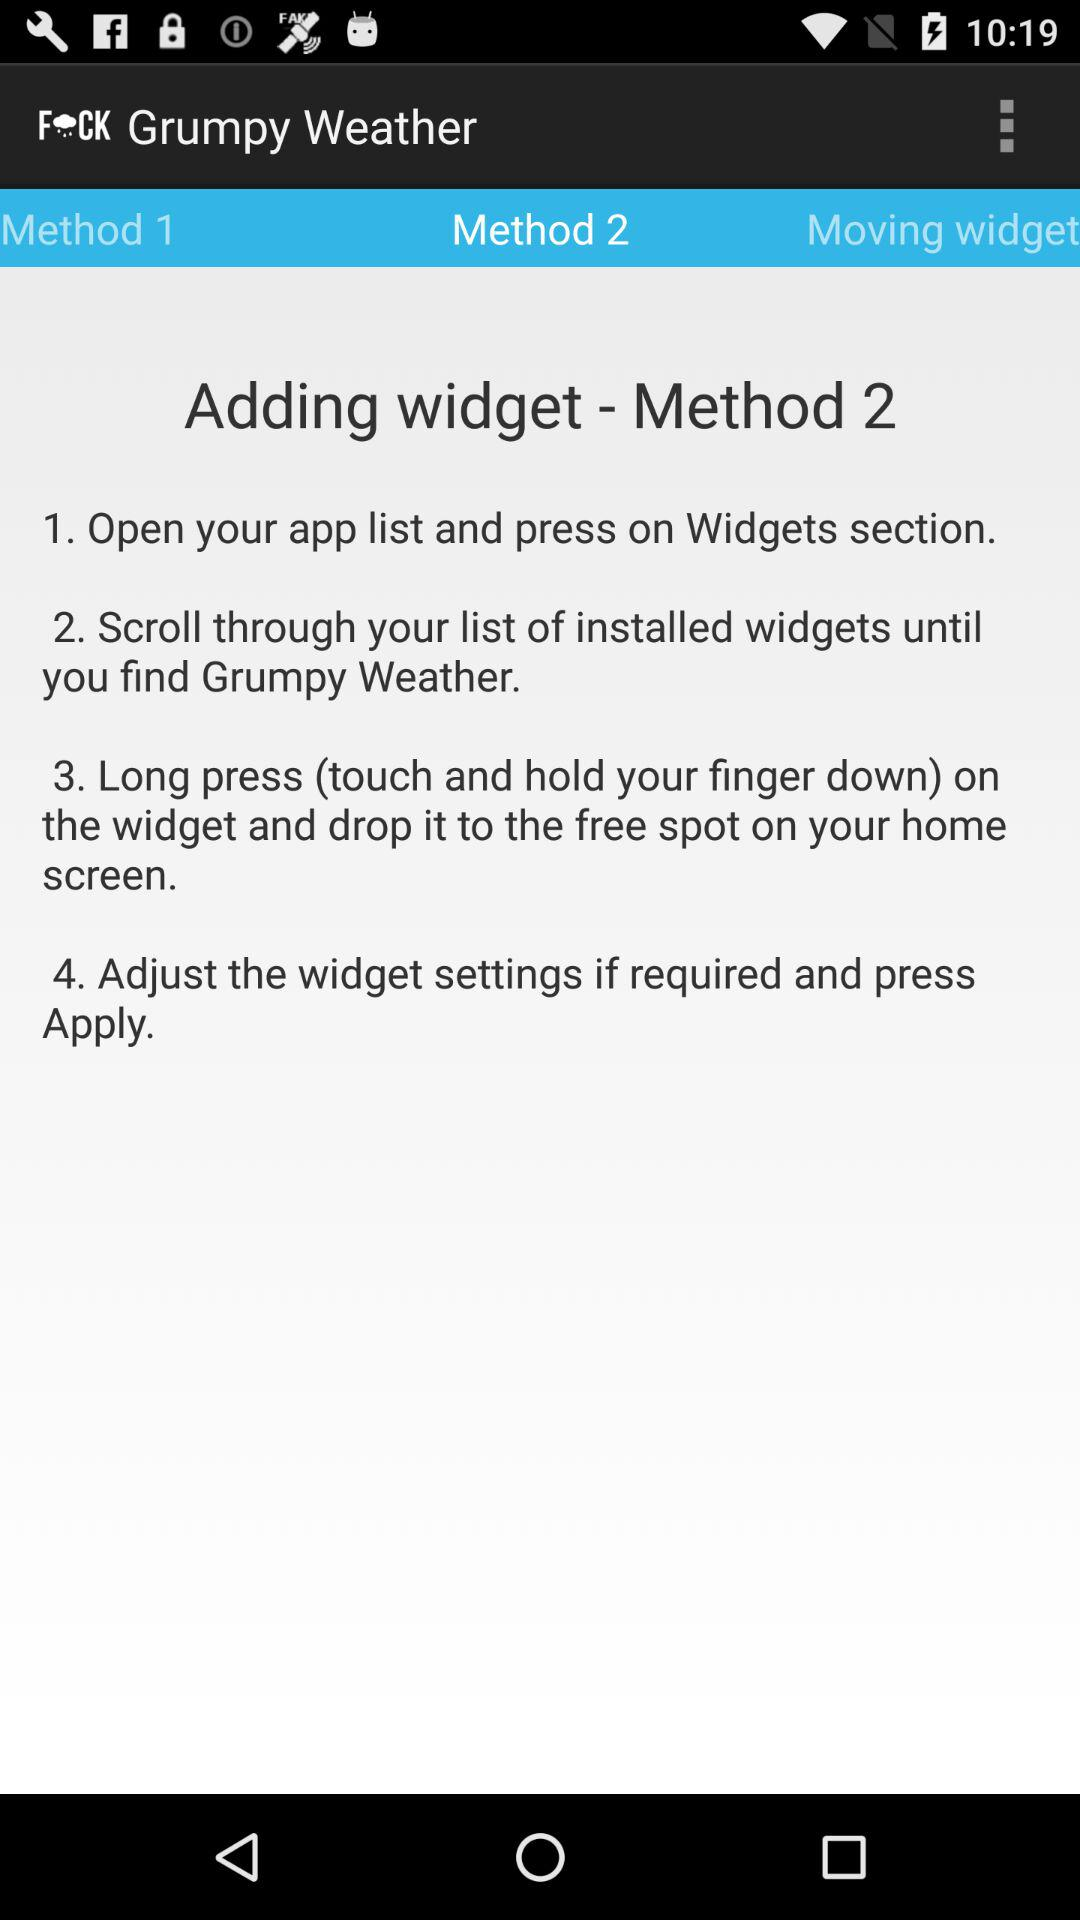What is the version of this application?
When the provided information is insufficient, respond with <no answer>. <no answer> 